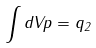<formula> <loc_0><loc_0><loc_500><loc_500>\int d V p = q _ { 2 }</formula> 